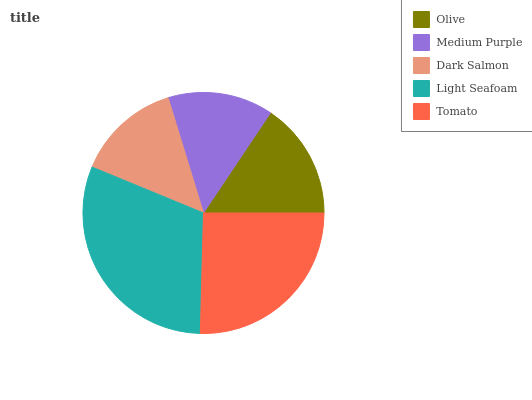Is Dark Salmon the minimum?
Answer yes or no. Yes. Is Light Seafoam the maximum?
Answer yes or no. Yes. Is Medium Purple the minimum?
Answer yes or no. No. Is Medium Purple the maximum?
Answer yes or no. No. Is Olive greater than Medium Purple?
Answer yes or no. Yes. Is Medium Purple less than Olive?
Answer yes or no. Yes. Is Medium Purple greater than Olive?
Answer yes or no. No. Is Olive less than Medium Purple?
Answer yes or no. No. Is Olive the high median?
Answer yes or no. Yes. Is Olive the low median?
Answer yes or no. Yes. Is Medium Purple the high median?
Answer yes or no. No. Is Medium Purple the low median?
Answer yes or no. No. 